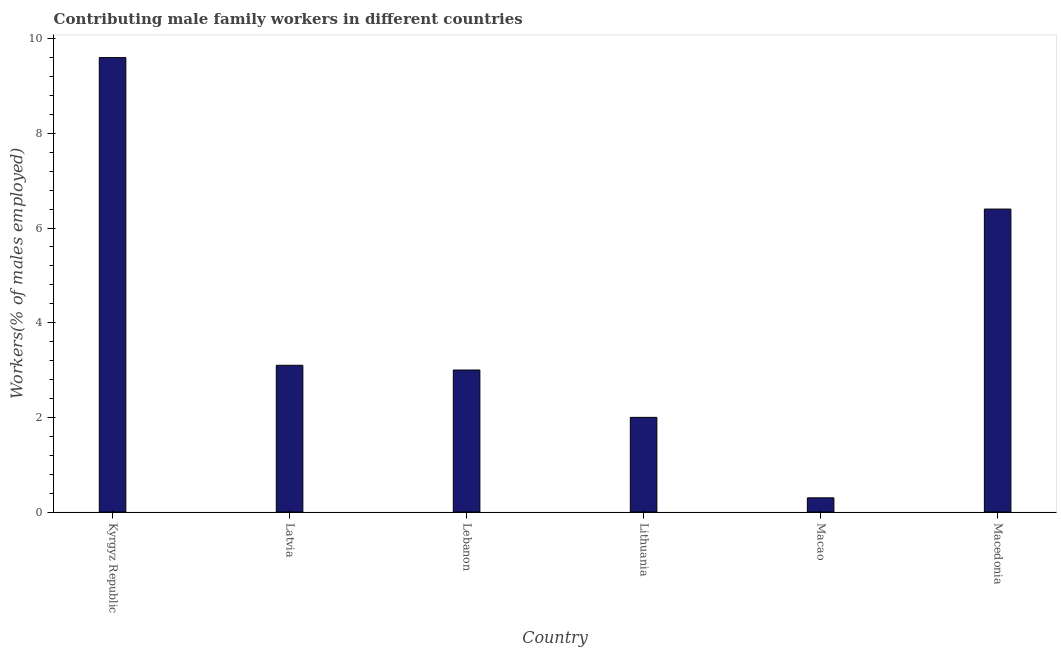Does the graph contain any zero values?
Ensure brevity in your answer.  No. Does the graph contain grids?
Your answer should be compact. No. What is the title of the graph?
Offer a very short reply. Contributing male family workers in different countries. What is the label or title of the Y-axis?
Give a very brief answer. Workers(% of males employed). What is the contributing male family workers in Macedonia?
Ensure brevity in your answer.  6.4. Across all countries, what is the maximum contributing male family workers?
Provide a succinct answer. 9.6. Across all countries, what is the minimum contributing male family workers?
Provide a short and direct response. 0.3. In which country was the contributing male family workers maximum?
Offer a terse response. Kyrgyz Republic. In which country was the contributing male family workers minimum?
Offer a terse response. Macao. What is the sum of the contributing male family workers?
Your answer should be compact. 24.4. What is the average contributing male family workers per country?
Offer a terse response. 4.07. What is the median contributing male family workers?
Keep it short and to the point. 3.05. In how many countries, is the contributing male family workers greater than 6 %?
Your answer should be compact. 2. What is the ratio of the contributing male family workers in Lithuania to that in Macao?
Ensure brevity in your answer.  6.67. Is the difference between the contributing male family workers in Lebanon and Lithuania greater than the difference between any two countries?
Offer a very short reply. No. How many countries are there in the graph?
Give a very brief answer. 6. What is the difference between two consecutive major ticks on the Y-axis?
Your answer should be compact. 2. Are the values on the major ticks of Y-axis written in scientific E-notation?
Provide a succinct answer. No. What is the Workers(% of males employed) in Kyrgyz Republic?
Your answer should be compact. 9.6. What is the Workers(% of males employed) of Latvia?
Offer a very short reply. 3.1. What is the Workers(% of males employed) of Macao?
Provide a succinct answer. 0.3. What is the Workers(% of males employed) of Macedonia?
Give a very brief answer. 6.4. What is the difference between the Workers(% of males employed) in Kyrgyz Republic and Latvia?
Keep it short and to the point. 6.5. What is the difference between the Workers(% of males employed) in Kyrgyz Republic and Lithuania?
Offer a very short reply. 7.6. What is the difference between the Workers(% of males employed) in Kyrgyz Republic and Macao?
Ensure brevity in your answer.  9.3. What is the difference between the Workers(% of males employed) in Kyrgyz Republic and Macedonia?
Ensure brevity in your answer.  3.2. What is the difference between the Workers(% of males employed) in Latvia and Lithuania?
Your answer should be compact. 1.1. What is the difference between the Workers(% of males employed) in Latvia and Macao?
Give a very brief answer. 2.8. What is the difference between the Workers(% of males employed) in Latvia and Macedonia?
Your answer should be compact. -3.3. What is the difference between the Workers(% of males employed) in Lebanon and Macao?
Offer a terse response. 2.7. What is the difference between the Workers(% of males employed) in Lebanon and Macedonia?
Give a very brief answer. -3.4. What is the difference between the Workers(% of males employed) in Lithuania and Macedonia?
Provide a short and direct response. -4.4. What is the difference between the Workers(% of males employed) in Macao and Macedonia?
Offer a terse response. -6.1. What is the ratio of the Workers(% of males employed) in Kyrgyz Republic to that in Latvia?
Your answer should be very brief. 3.1. What is the ratio of the Workers(% of males employed) in Latvia to that in Lebanon?
Give a very brief answer. 1.03. What is the ratio of the Workers(% of males employed) in Latvia to that in Lithuania?
Provide a succinct answer. 1.55. What is the ratio of the Workers(% of males employed) in Latvia to that in Macao?
Keep it short and to the point. 10.33. What is the ratio of the Workers(% of males employed) in Latvia to that in Macedonia?
Make the answer very short. 0.48. What is the ratio of the Workers(% of males employed) in Lebanon to that in Lithuania?
Offer a terse response. 1.5. What is the ratio of the Workers(% of males employed) in Lebanon to that in Macedonia?
Keep it short and to the point. 0.47. What is the ratio of the Workers(% of males employed) in Lithuania to that in Macao?
Offer a terse response. 6.67. What is the ratio of the Workers(% of males employed) in Lithuania to that in Macedonia?
Your response must be concise. 0.31. What is the ratio of the Workers(% of males employed) in Macao to that in Macedonia?
Give a very brief answer. 0.05. 